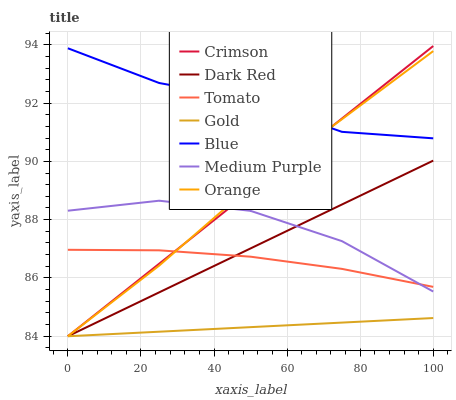Does Gold have the minimum area under the curve?
Answer yes or no. Yes. Does Blue have the maximum area under the curve?
Answer yes or no. Yes. Does Blue have the minimum area under the curve?
Answer yes or no. No. Does Gold have the maximum area under the curve?
Answer yes or no. No. Is Crimson the smoothest?
Answer yes or no. Yes. Is Medium Purple the roughest?
Answer yes or no. Yes. Is Blue the smoothest?
Answer yes or no. No. Is Blue the roughest?
Answer yes or no. No. Does Blue have the lowest value?
Answer yes or no. No. Does Crimson have the highest value?
Answer yes or no. Yes. Does Blue have the highest value?
Answer yes or no. No. Is Gold less than Tomato?
Answer yes or no. Yes. Is Blue greater than Medium Purple?
Answer yes or no. Yes. Does Medium Purple intersect Tomato?
Answer yes or no. Yes. Is Medium Purple less than Tomato?
Answer yes or no. No. Is Medium Purple greater than Tomato?
Answer yes or no. No. Does Gold intersect Tomato?
Answer yes or no. No. 